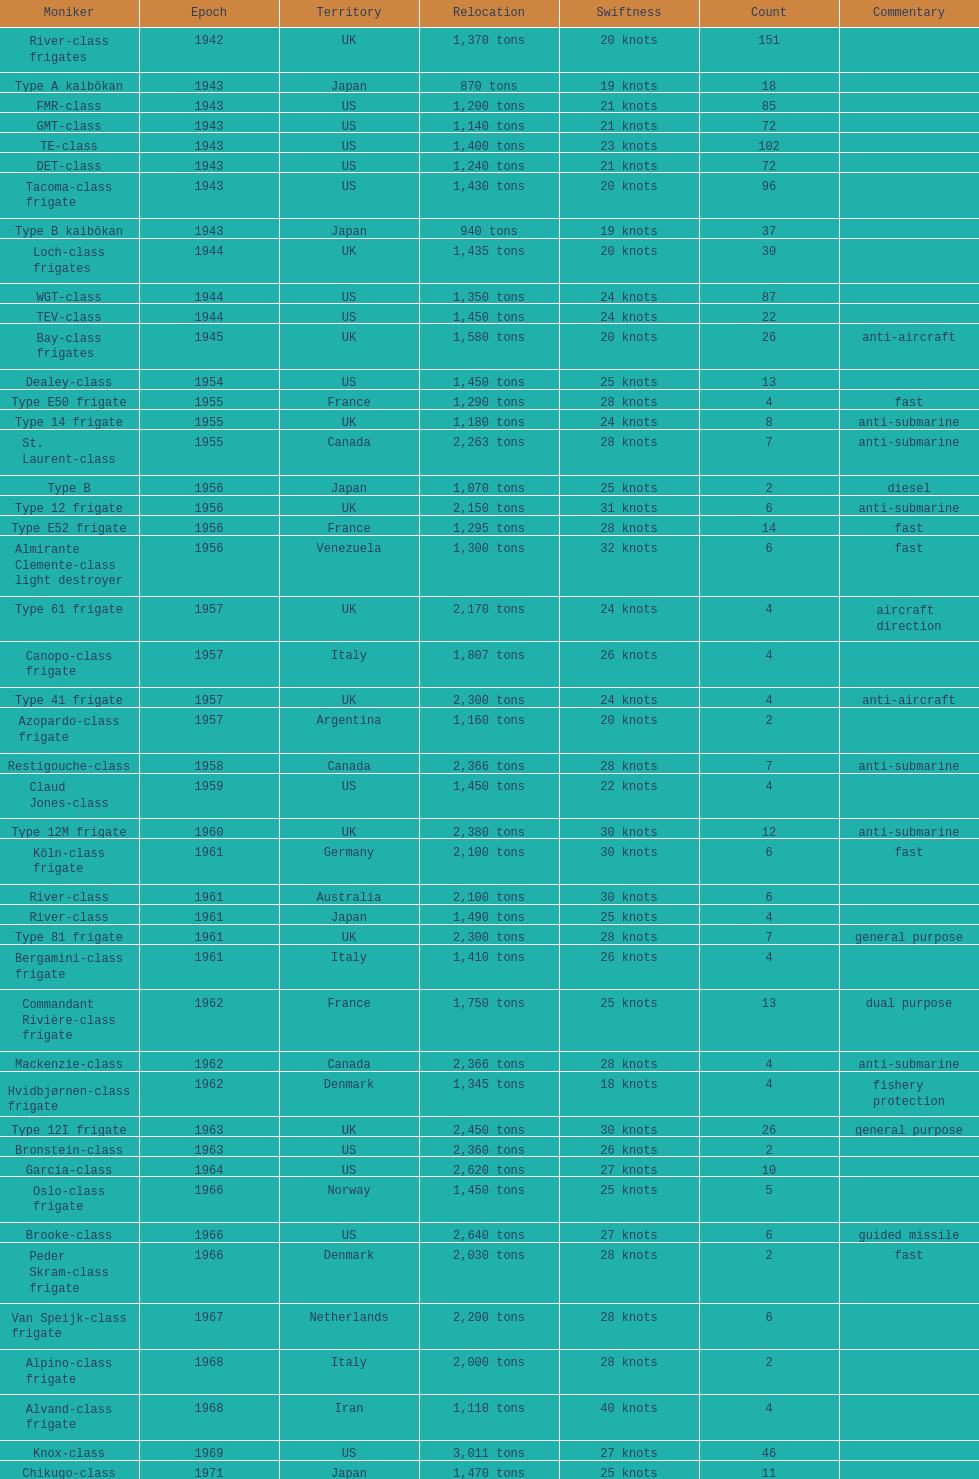How many tons does the te-class displace? 1,400 tons. 